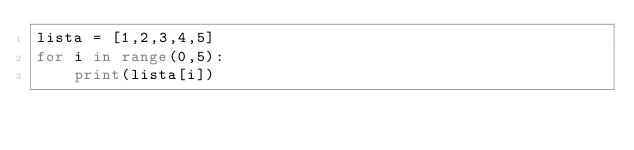<code> <loc_0><loc_0><loc_500><loc_500><_Python_>lista = [1,2,3,4,5]
for i in range(0,5):
    print(lista[i])
    </code> 